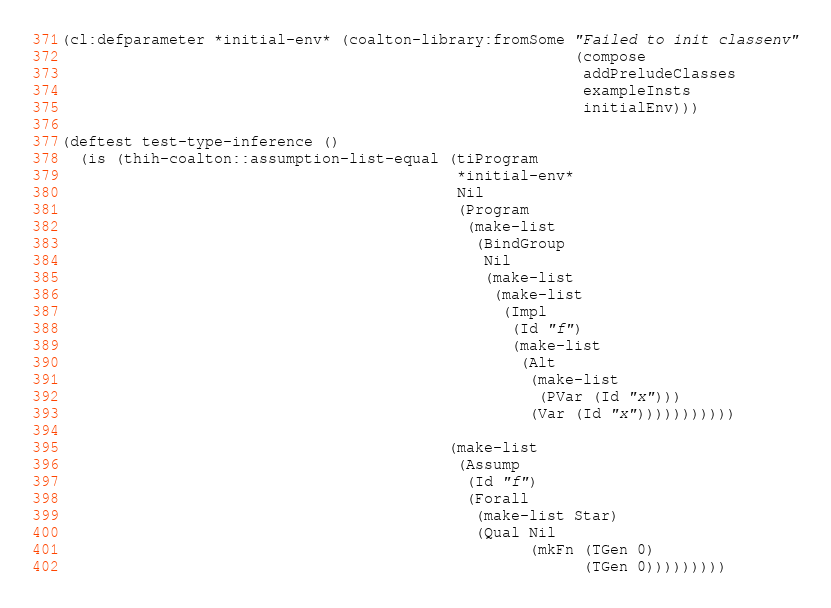<code> <loc_0><loc_0><loc_500><loc_500><_Lisp_>(cl:defparameter *initial-env* (coalton-library:fromSome "Failed to init classenv"
                                                         (compose
                                                          addPreludeClasses
                                                          exampleInsts
                                                          initialEnv)))

(deftest test-type-inference ()
  (is (thih-coalton::assumption-list-equal (tiProgram
                                            *initial-env*
                                            Nil
                                            (Program
                                             (make-list
                                              (BindGroup
                                               Nil
                                               (make-list
                                                (make-list
                                                 (Impl
                                                  (Id "f")
                                                  (make-list
                                                   (Alt
                                                    (make-list
                                                     (PVar (Id "x")))
                                                    (Var (Id "x")))))))))))
              
                                           (make-list
                                            (Assump
                                             (Id "f")
                                             (Forall
                                              (make-list Star)
                                              (Qual Nil
                                                    (mkFn (TGen 0)
                                                          (TGen 0)))))))))
</code> 